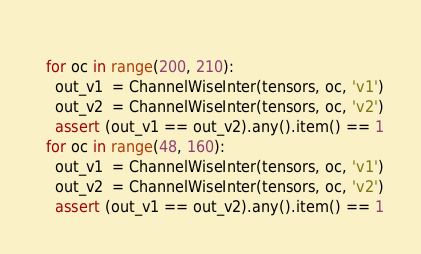<code> <loc_0><loc_0><loc_500><loc_500><_Python_>  
  for oc in range(200, 210):
    out_v1  = ChannelWiseInter(tensors, oc, 'v1')
    out_v2  = ChannelWiseInter(tensors, oc, 'v2')
    assert (out_v1 == out_v2).any().item() == 1
  for oc in range(48, 160):
    out_v1  = ChannelWiseInter(tensors, oc, 'v1')
    out_v2  = ChannelWiseInter(tensors, oc, 'v2')
    assert (out_v1 == out_v2).any().item() == 1
</code> 